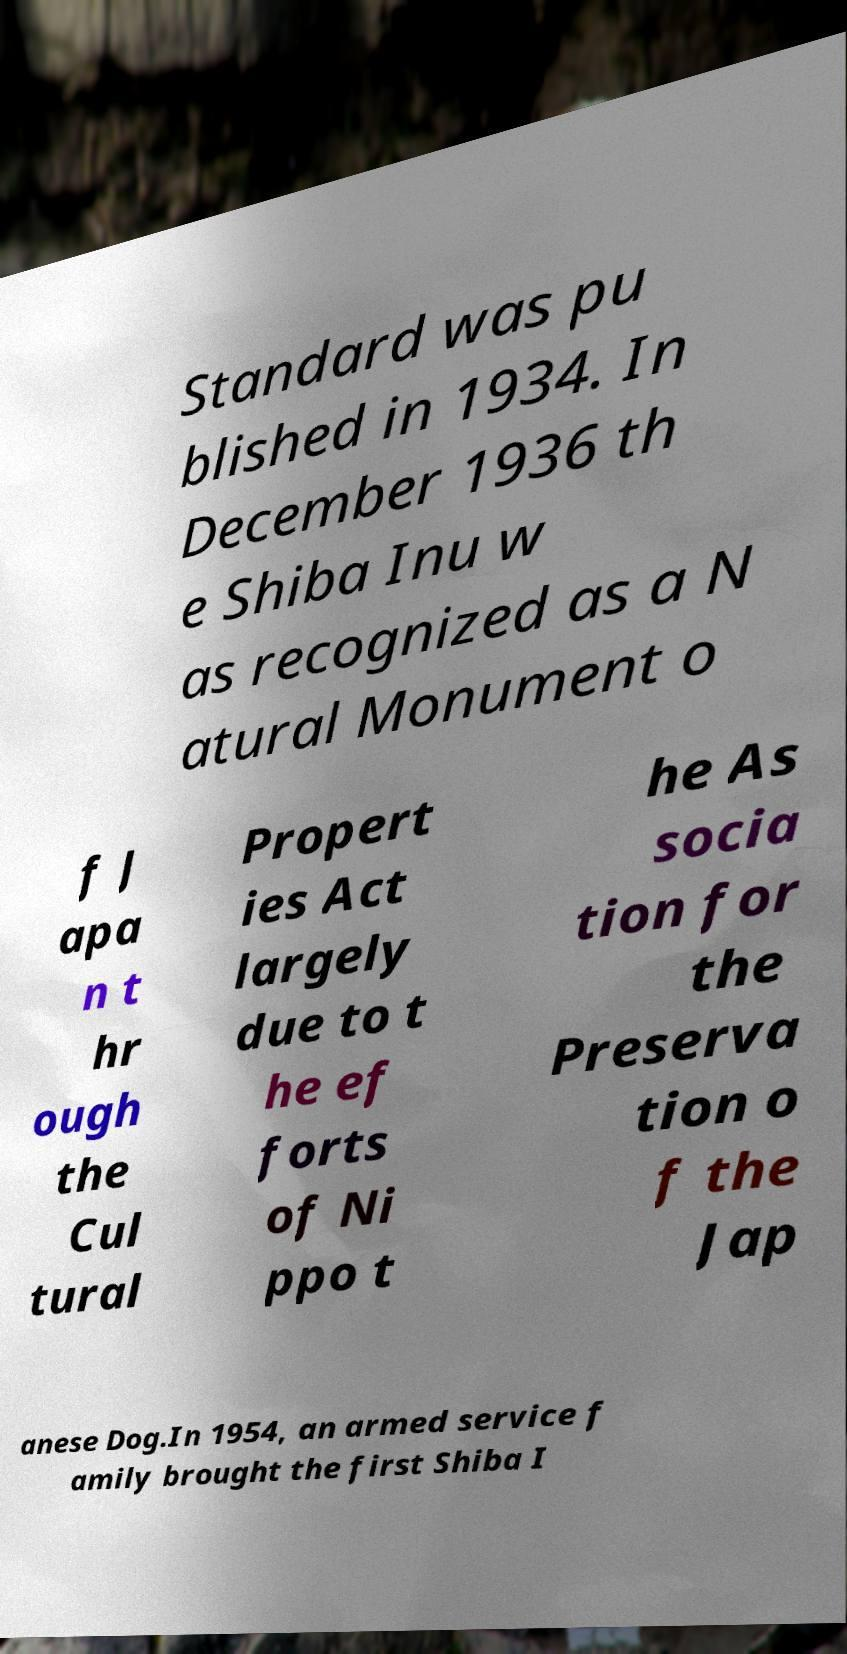Please read and relay the text visible in this image. What does it say? Standard was pu blished in 1934. In December 1936 th e Shiba Inu w as recognized as a N atural Monument o f J apa n t hr ough the Cul tural Propert ies Act largely due to t he ef forts of Ni ppo t he As socia tion for the Preserva tion o f the Jap anese Dog.In 1954, an armed service f amily brought the first Shiba I 